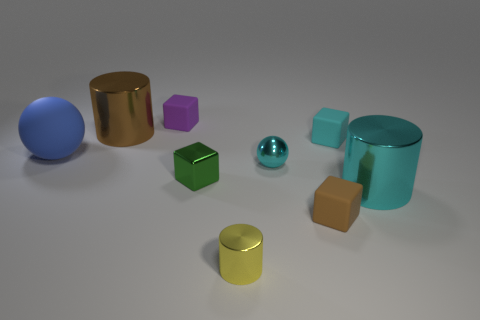Subtract all large brown metallic cylinders. How many cylinders are left? 2 Add 1 big brown cylinders. How many objects exist? 10 Subtract all cyan cylinders. How many cylinders are left? 2 Subtract 2 cylinders. How many cylinders are left? 1 Subtract all brown cylinders. How many red blocks are left? 0 Subtract all cylinders. How many objects are left? 6 Subtract all purple rubber blocks. Subtract all cyan objects. How many objects are left? 5 Add 8 tiny cyan matte blocks. How many tiny cyan matte blocks are left? 9 Add 6 yellow cylinders. How many yellow cylinders exist? 7 Subtract 1 cyan balls. How many objects are left? 8 